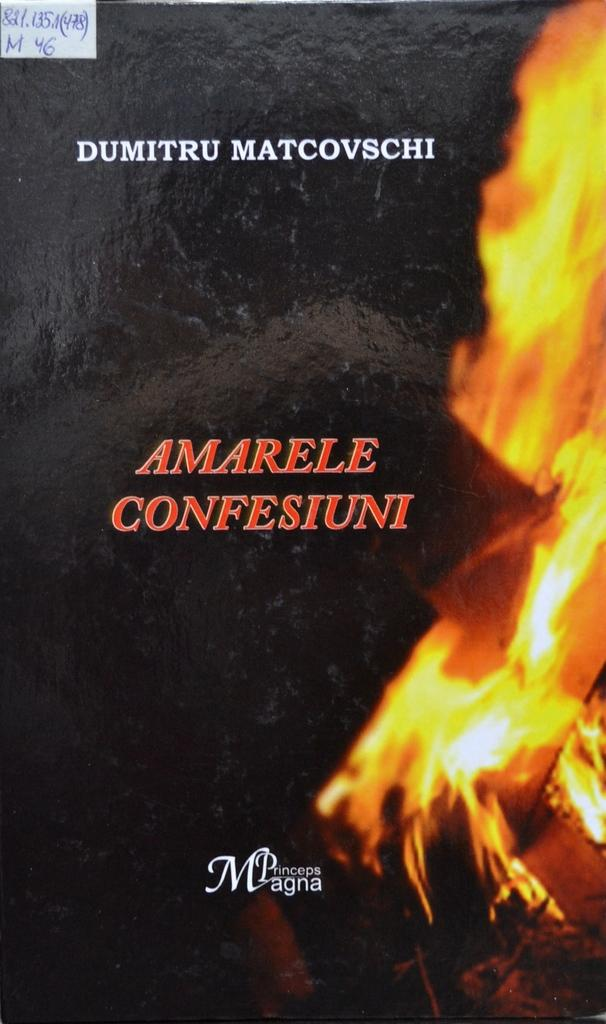<image>
Provide a brief description of the given image. A book cover has fire on it and the title Amarele Confesiuni. 